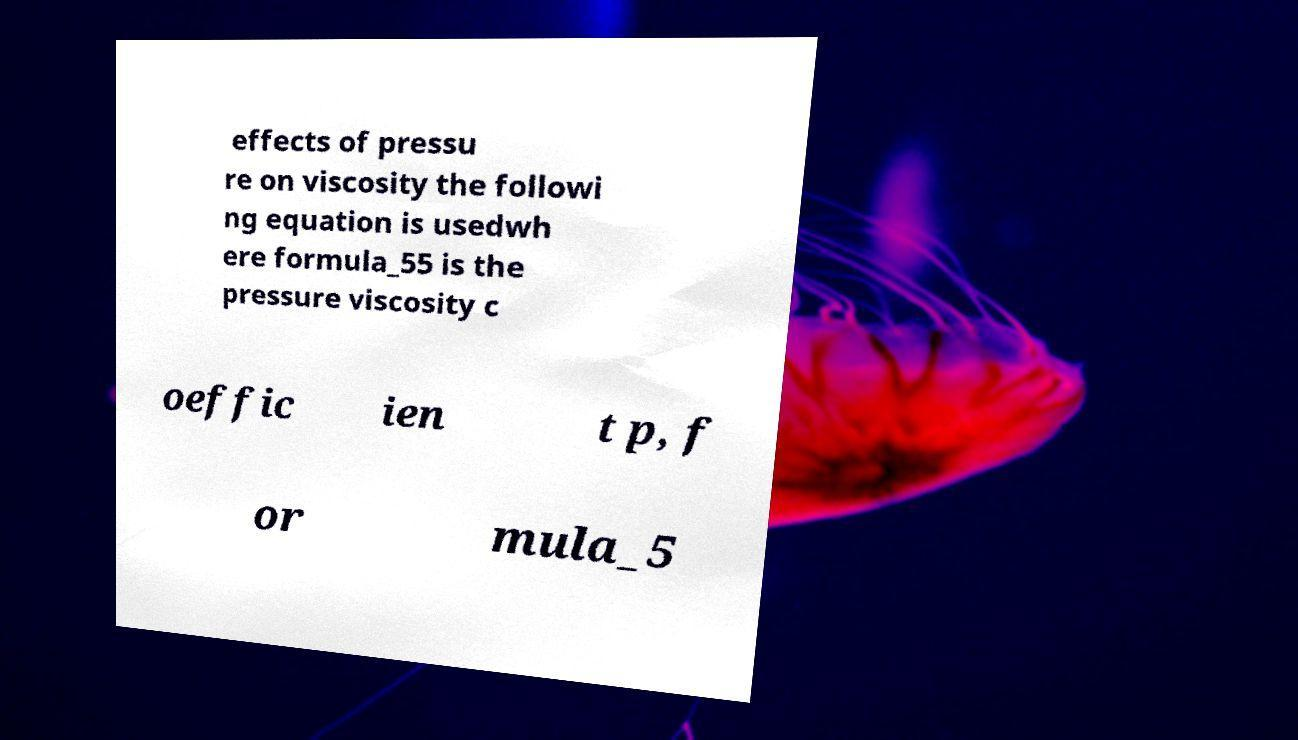For documentation purposes, I need the text within this image transcribed. Could you provide that? effects of pressu re on viscosity the followi ng equation is usedwh ere formula_55 is the pressure viscosity c oeffic ien t p, f or mula_5 